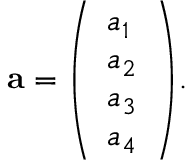<formula> <loc_0><loc_0><loc_500><loc_500>a = { \left ( \begin{array} { l } { a _ { 1 } } \\ { a _ { 2 } } \\ { a _ { 3 } } \\ { a _ { 4 } } \end{array} \right ) } .</formula> 